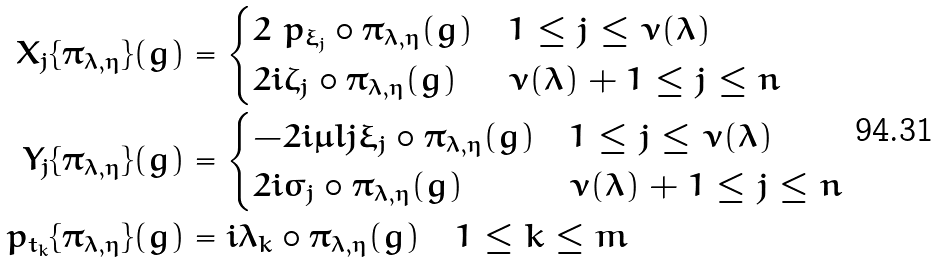<formula> <loc_0><loc_0><loc_500><loc_500>X _ { j } \{ \pi _ { \lambda , \eta } \} ( g ) & = \begin{cases} 2 \ p _ { \xi _ { j } } \circ \pi _ { \lambda , \eta } ( g ) & 1 \leq j \leq { \nu ( \lambda ) } \\ 2 i \zeta _ { j } \circ \pi _ { \lambda , \eta } ( g ) & { \nu ( \lambda ) } + 1 \leq j \leq n \end{cases} \\ Y _ { j } \{ \pi _ { \lambda , \eta } \} ( g ) & = \begin{cases} - 2 i \mu l j \xi _ { j } \circ \pi _ { \lambda , \eta } ( g ) & 1 \leq j \leq { \nu ( \lambda ) } \\ 2 i \varsigma _ { j } \circ \pi _ { \lambda , \eta } ( g ) & { \nu ( \lambda ) } + 1 \leq j \leq n \end{cases} \\ \ p _ { t _ { k } } \{ \pi _ { \lambda , \eta } \} ( g ) & = i \lambda _ { k } \circ \pi _ { \lambda , \eta } ( g ) \quad 1 \leq k \leq m</formula> 